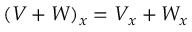Convert formula to latex. <formula><loc_0><loc_0><loc_500><loc_500>( V + W ) _ { x } = V _ { x } + W _ { x }</formula> 